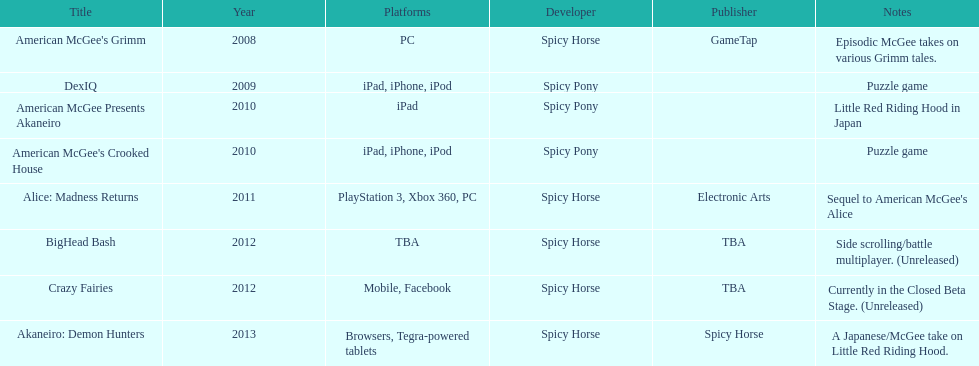What are the number of times an ipad was used as a platform? 3. 